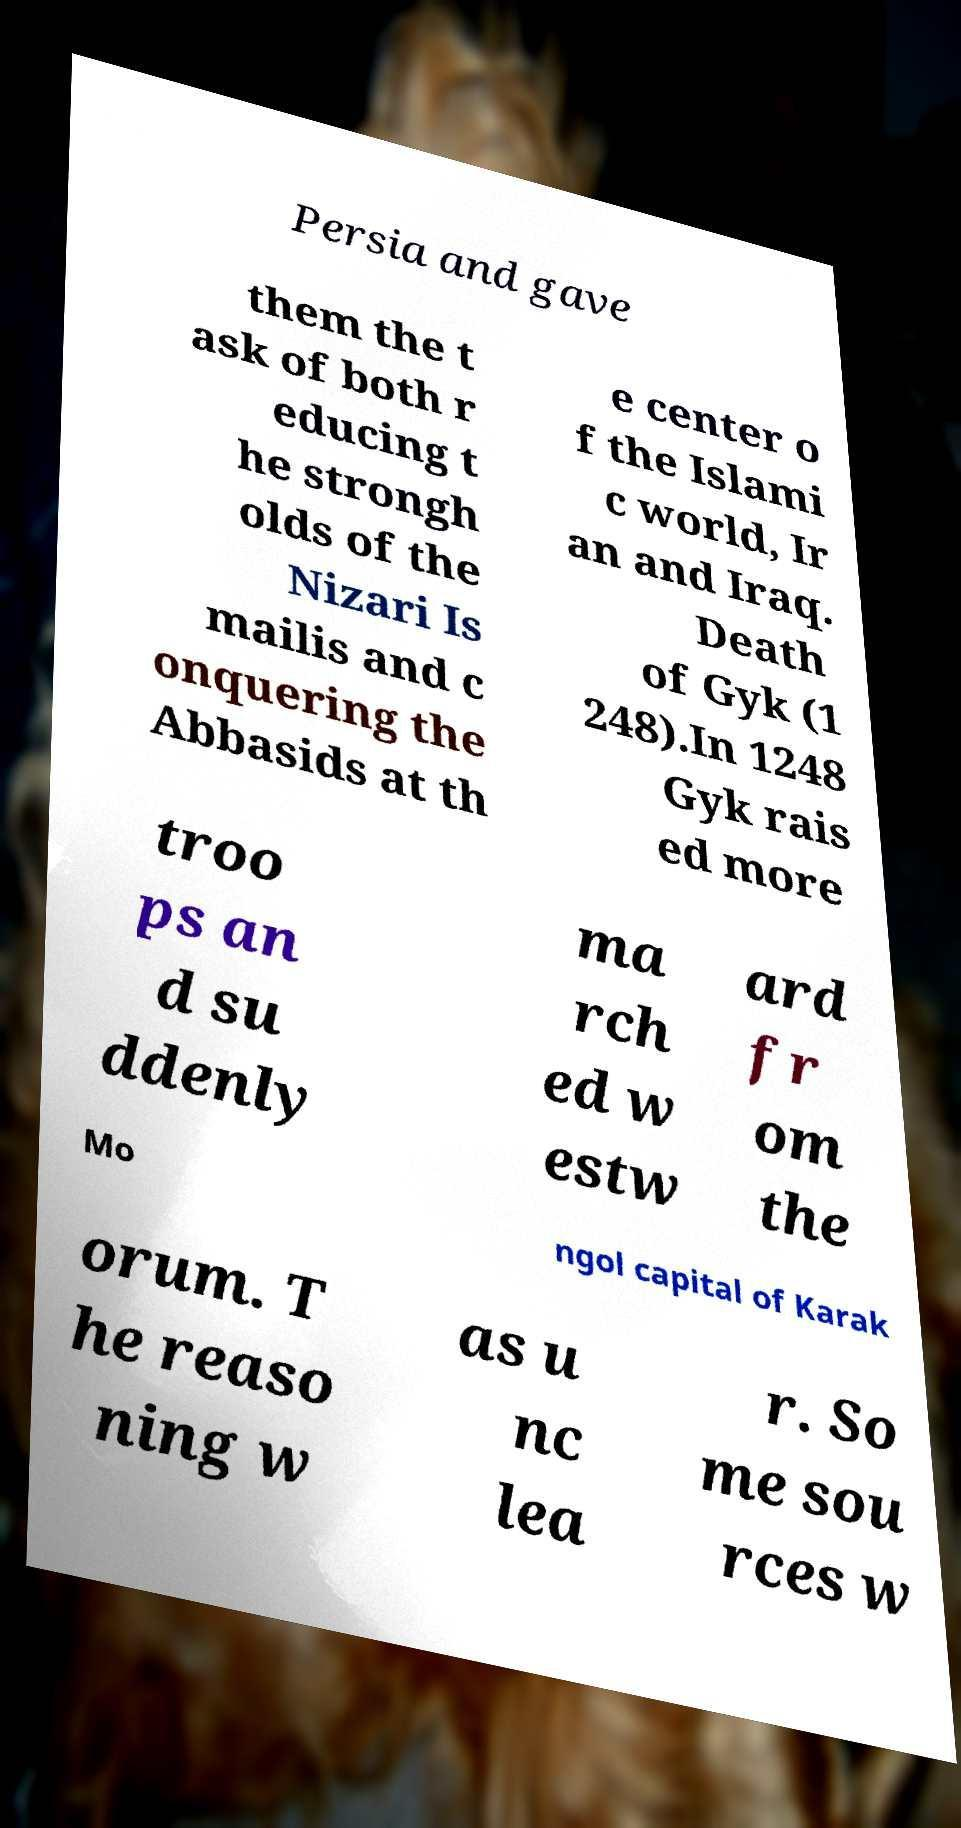Can you accurately transcribe the text from the provided image for me? Persia and gave them the t ask of both r educing t he strongh olds of the Nizari Is mailis and c onquering the Abbasids at th e center o f the Islami c world, Ir an and Iraq. Death of Gyk (1 248).In 1248 Gyk rais ed more troo ps an d su ddenly ma rch ed w estw ard fr om the Mo ngol capital of Karak orum. T he reaso ning w as u nc lea r. So me sou rces w 